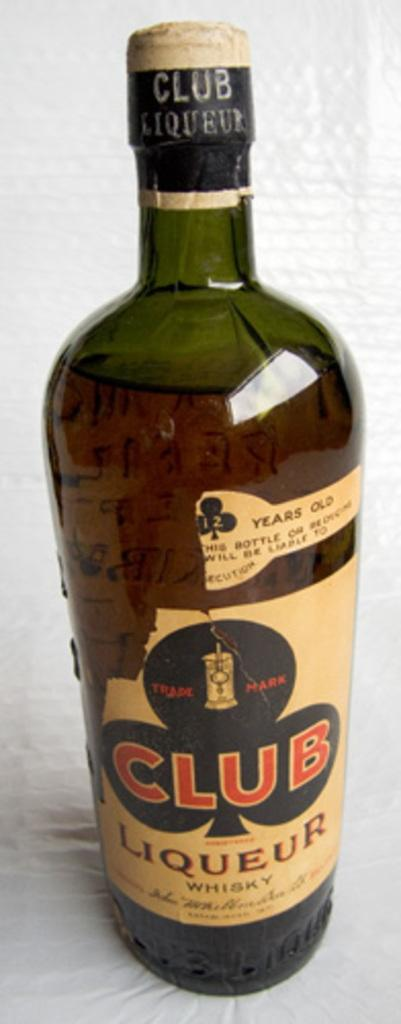<image>
Give a short and clear explanation of the subsequent image. A club symbol decorates the label of a bottle of Club Liqueur. 